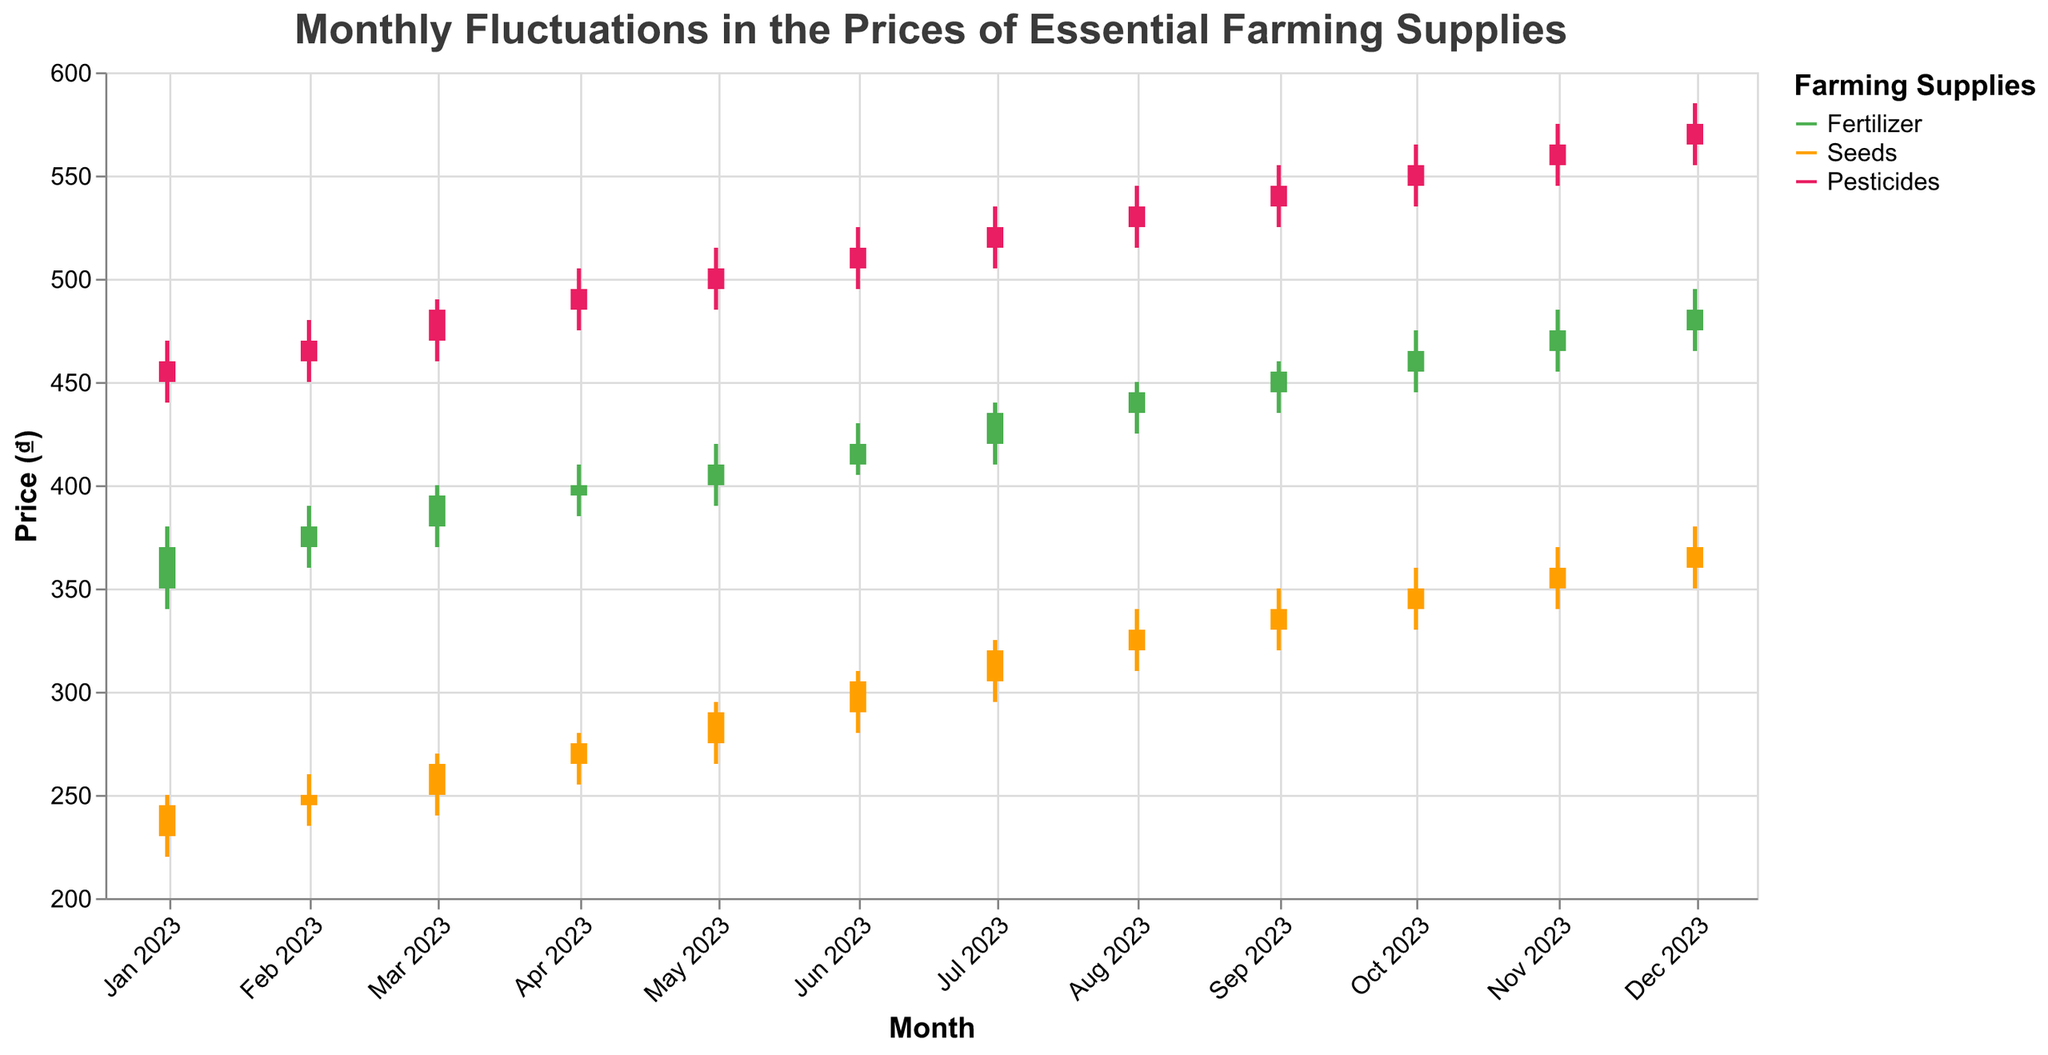What's the title of the figure? The title of the figure is usually found at the top and is used to give a brief description of what the figure illustrates.
Answer: Monthly Fluctuations in the Prices of Essential Farming Supplies What is the price range of Fertilizer in January 2023? To find the price range of Fertilizer in January 2023, locate the low and high prices. The low price is 340 and the high price is 380. The price range is the difference between high and low prices, which is 380 - 340.
Answer: 40 Which farming supply had the highest closing price in December 2023? Look at the closing prices for each supply in December 2023. Fertilizer has a closing price of 485, Seeds has 370, and Pesticides has 575. The highest closing price is for Pesticides.
Answer: Pesticides How did the closing price of Seeds change from January 2023 to December 2023? Find the closing prices for Seeds in both months. The closing price in January 2023 is 245, and in December 2023 it is 370. The change is 370 - 245.
Answer: Increased by 125 In which month did Fertilizer have the highest trading volume? Look at the volume data for Fertilizer. The highest trading volume for Fertilizer is 1950 in December.
Answer: December 2023 Compare the closing prices of Pesticides and Fertilizer in June 2023. Which one is higher? Find the closing prices: Pesticides have a closing price of 515 and Fertilizer has a closing price of 420. Pesticides have a higher closing price.
Answer: Pesticides What was the trend in Fertilizer prices from January 2023 to December 2023? Observe the closing prices of Fertilizer from January (370) to December (485). Notice the month-to-month changes indicating an overall increasing trend.
Answer: Increasing trend What is the average closing price of Seeds in the first quarter (Jan-Mar) of 2023? Calculate the average by summing the closing prices for Seeds in January (245), February (250), and March (265), then dividing by 3. The sum is 245 + 250 + 265 = 760. The average is 760 / 3.
Answer: 253.33 Did the closing price of Pesticides ever decrease two consecutive months in 2023? Check the closing prices of Pesticides each month. Look for two consecutive months where the closing price decreased from the previous month. No consecutive decreases are observed.
Answer: No 